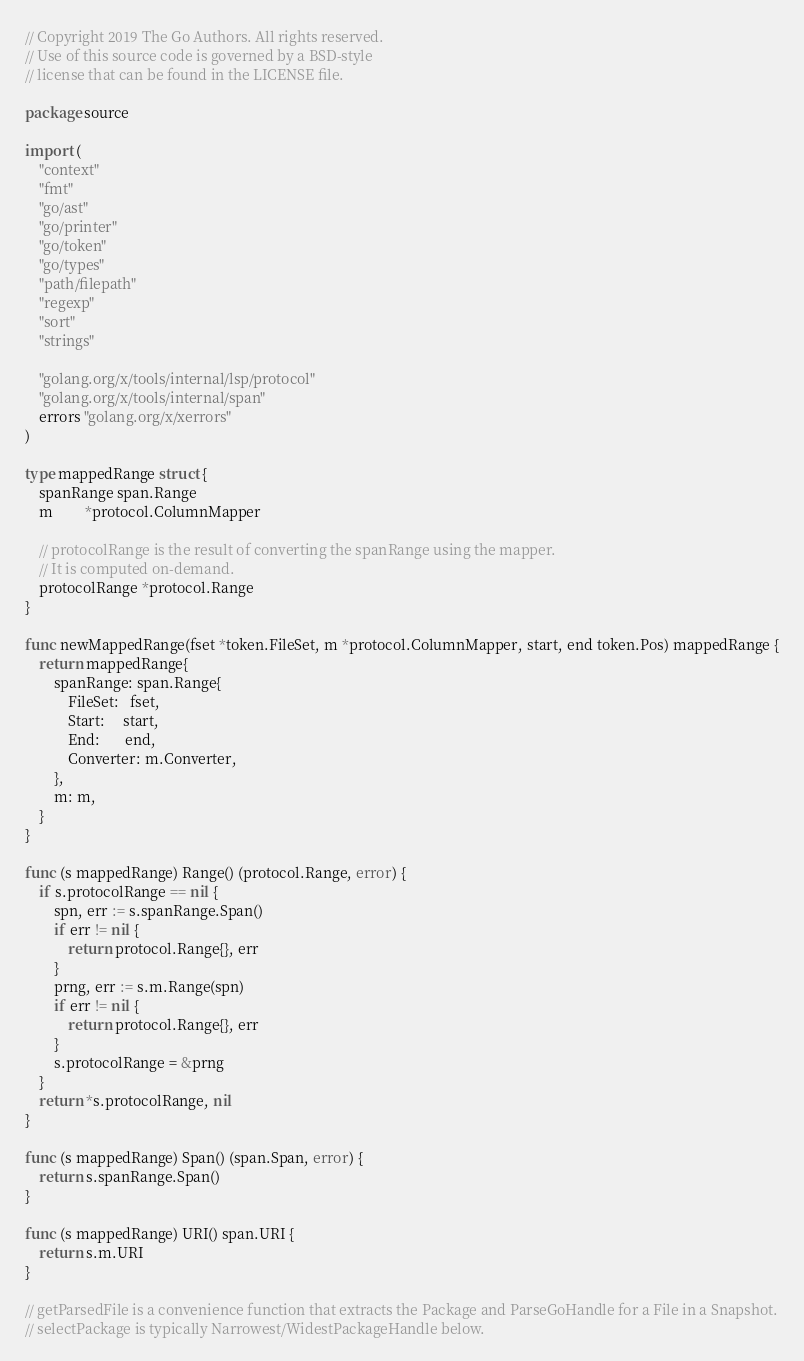<code> <loc_0><loc_0><loc_500><loc_500><_Go_>// Copyright 2019 The Go Authors. All rights reserved.
// Use of this source code is governed by a BSD-style
// license that can be found in the LICENSE file.

package source

import (
	"context"
	"fmt"
	"go/ast"
	"go/printer"
	"go/token"
	"go/types"
	"path/filepath"
	"regexp"
	"sort"
	"strings"

	"golang.org/x/tools/internal/lsp/protocol"
	"golang.org/x/tools/internal/span"
	errors "golang.org/x/xerrors"
)

type mappedRange struct {
	spanRange span.Range
	m         *protocol.ColumnMapper

	// protocolRange is the result of converting the spanRange using the mapper.
	// It is computed on-demand.
	protocolRange *protocol.Range
}

func newMappedRange(fset *token.FileSet, m *protocol.ColumnMapper, start, end token.Pos) mappedRange {
	return mappedRange{
		spanRange: span.Range{
			FileSet:   fset,
			Start:     start,
			End:       end,
			Converter: m.Converter,
		},
		m: m,
	}
}

func (s mappedRange) Range() (protocol.Range, error) {
	if s.protocolRange == nil {
		spn, err := s.spanRange.Span()
		if err != nil {
			return protocol.Range{}, err
		}
		prng, err := s.m.Range(spn)
		if err != nil {
			return protocol.Range{}, err
		}
		s.protocolRange = &prng
	}
	return *s.protocolRange, nil
}

func (s mappedRange) Span() (span.Span, error) {
	return s.spanRange.Span()
}

func (s mappedRange) URI() span.URI {
	return s.m.URI
}

// getParsedFile is a convenience function that extracts the Package and ParseGoHandle for a File in a Snapshot.
// selectPackage is typically Narrowest/WidestPackageHandle below.</code> 